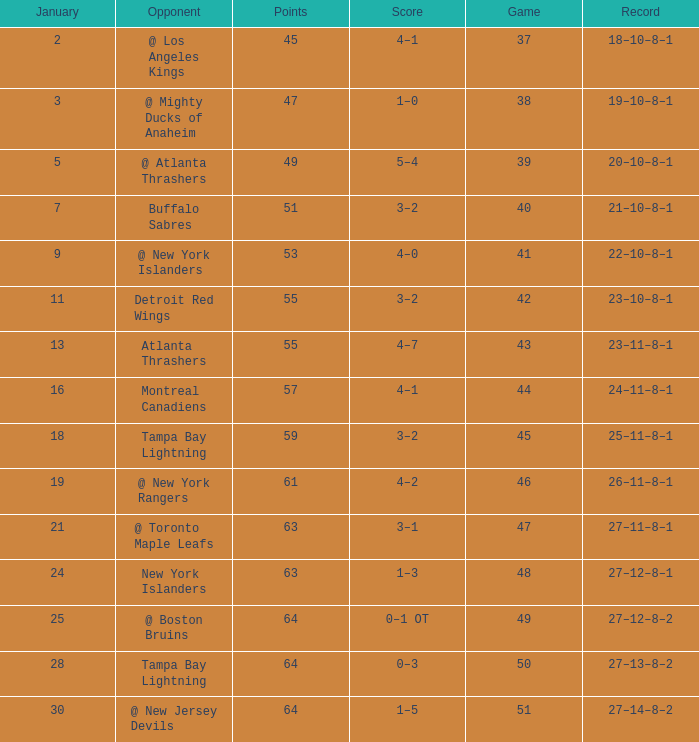Write the full table. {'header': ['January', 'Opponent', 'Points', 'Score', 'Game', 'Record'], 'rows': [['2', '@ Los Angeles Kings', '45', '4–1', '37', '18–10–8–1'], ['3', '@ Mighty Ducks of Anaheim', '47', '1–0', '38', '19–10–8–1'], ['5', '@ Atlanta Thrashers', '49', '5–4', '39', '20–10–8–1'], ['7', 'Buffalo Sabres', '51', '3–2', '40', '21–10–8–1'], ['9', '@ New York Islanders', '53', '4–0', '41', '22–10–8–1'], ['11', 'Detroit Red Wings', '55', '3–2', '42', '23–10–8–1'], ['13', 'Atlanta Thrashers', '55', '4–7', '43', '23–11–8–1'], ['16', 'Montreal Canadiens', '57', '4–1', '44', '24–11–8–1'], ['18', 'Tampa Bay Lightning', '59', '3–2', '45', '25–11–8–1'], ['19', '@ New York Rangers', '61', '4–2', '46', '26–11–8–1'], ['21', '@ Toronto Maple Leafs', '63', '3–1', '47', '27–11–8–1'], ['24', 'New York Islanders', '63', '1–3', '48', '27–12–8–1'], ['25', '@ Boston Bruins', '64', '0–1 OT', '49', '27–12–8–2'], ['28', 'Tampa Bay Lightning', '64', '0–3', '50', '27–13–8–2'], ['30', '@ New Jersey Devils', '64', '1–5', '51', '27–14–8–2']]} How many Points have a January of 18? 1.0. 